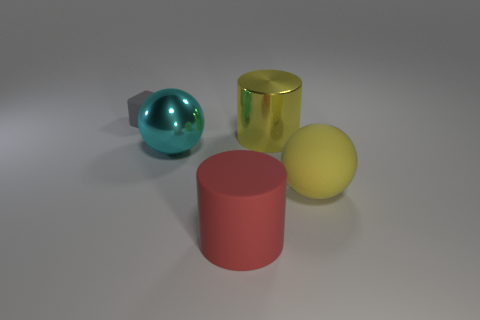Is there anything else that has the same shape as the small thing?
Offer a terse response. No. Are there any other things that have the same size as the gray block?
Your response must be concise. No. Is the shape of the cyan object the same as the rubber thing on the right side of the red cylinder?
Ensure brevity in your answer.  Yes. Are there any big metal objects that have the same color as the matte ball?
Your answer should be very brief. Yes. The cyan ball that is the same material as the large yellow cylinder is what size?
Your answer should be very brief. Large. Do the metal cylinder and the rubber sphere have the same color?
Your answer should be compact. Yes. Does the large cyan metal thing on the left side of the red object have the same shape as the yellow matte thing?
Your answer should be very brief. Yes. What number of purple rubber cylinders have the same size as the matte ball?
Your response must be concise. 0. What is the shape of the large metal object that is the same color as the rubber ball?
Your response must be concise. Cylinder. Are there any large metal objects left of the big cylinder in front of the cyan metal ball?
Your response must be concise. Yes. 